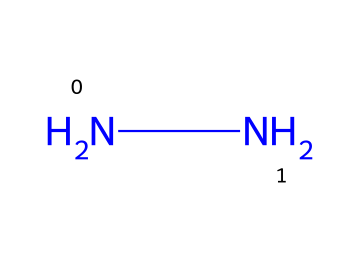what is the molecular formula of this chemical? The chemical structure provided is represented by the SMILES notation 'NN', which indicates there are two nitrogen atoms and no carbon or other elements present. Therefore, the molecular formula is determined by the count of each type of atom in the structure.
Answer: N2H4 how many nitrogen atoms are in the structure? The SMILES notation 'NN' directly indicates there are two nitrogen atoms connected to each other. This is a straightforward count based on the visual representation of the chemical.
Answer: 2 what type of chemical bond is present in this structure? The bond between the two nitrogen atoms in the SMILES representation 'NN' is a covalent bond. This is identified by observing that two nonmetals (nitrogen) share electrons, leading to the formation of a covalent bond.
Answer: covalent what property of hydrazine makes it suitable for rocket fuel? Hydrazine is highly reactive and has a high energy density, which makes it an effective propellant in rocket fuel applications. This is due to its ability to release a significant amount of energy when it decomposes or reacts with oxidizers, an important factor for propulsion.
Answer: reactivity how many hydrogen atoms are in the chemical structure of hydrazine? While the SMILES representation 'NN' only shows the nitrogen atoms, hydrazine is known to have a molecular formula of N2H4, indicating that there are four hydrogen atoms present. This can be derived from the complete structural understanding of hydrazine, which includes these hydrogen atoms.
Answer: 4 what unique property does hydrazine have that can be exploited in propulsion systems? Hydrazine acts as a hypergolic propellant, igniting spontaneously upon contact with an oxidizer without requiring an external ignition source. This is critical for reliability in various rocket engine designs.
Answer: hypergolic how does the structure of hydrazine affect its applications in the aerospace field? The simple di-nitrogen structure of hydrazine (indicated by 'NN') allows for easy modification and various chemical reactions that can be tailored for specific propulsion needs, which highlights its flexibility and effectiveness in aerospace applications.
Answer: simple structure 